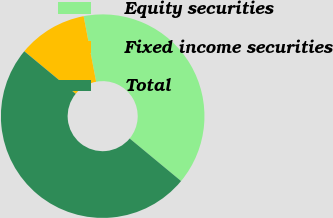<chart> <loc_0><loc_0><loc_500><loc_500><pie_chart><fcel>Equity securities<fcel>Fixed income securities<fcel>Total<nl><fcel>39.0%<fcel>11.0%<fcel>50.0%<nl></chart> 